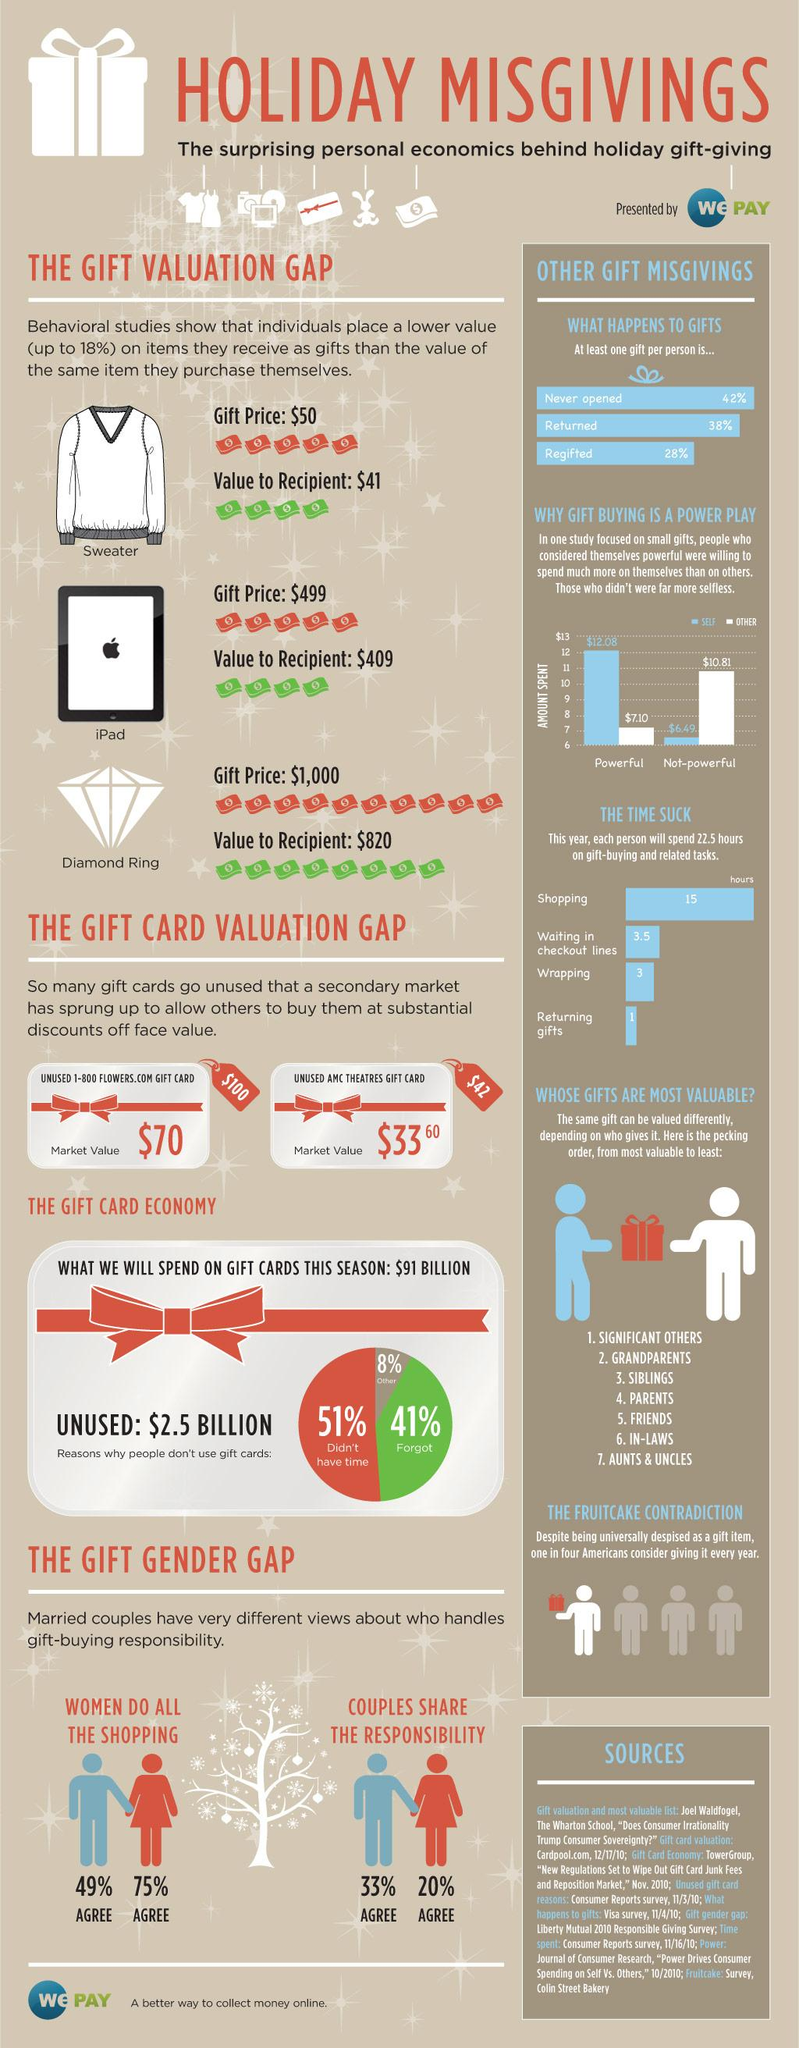Draw attention to some important aspects in this diagram. The powerful individual spent significantly more money on themselves than on others, amounting to 4.98 dollars. The recipient of an iPad as a gift perceives its value to be 90% less than its actual value. In total, people will spend approximately 6.5 hours wrapping gifts or waiting in checkout lines. The perceived value of a diamond ring as a gift is significantly less than its actual value, by 180%. According to the data, approximately 49% of people either forget or have other reasons for not using gift cards. 